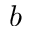<formula> <loc_0><loc_0><loc_500><loc_500>b</formula> 